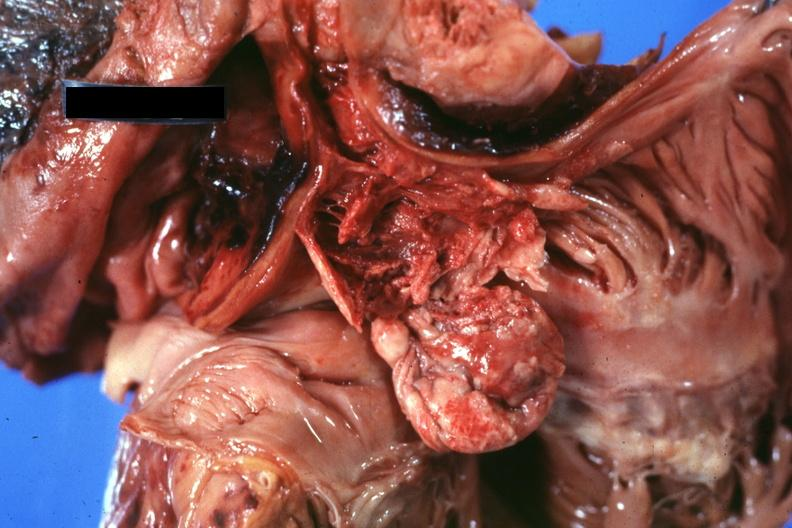s hematologic present?
Answer the question using a single word or phrase. Yes 